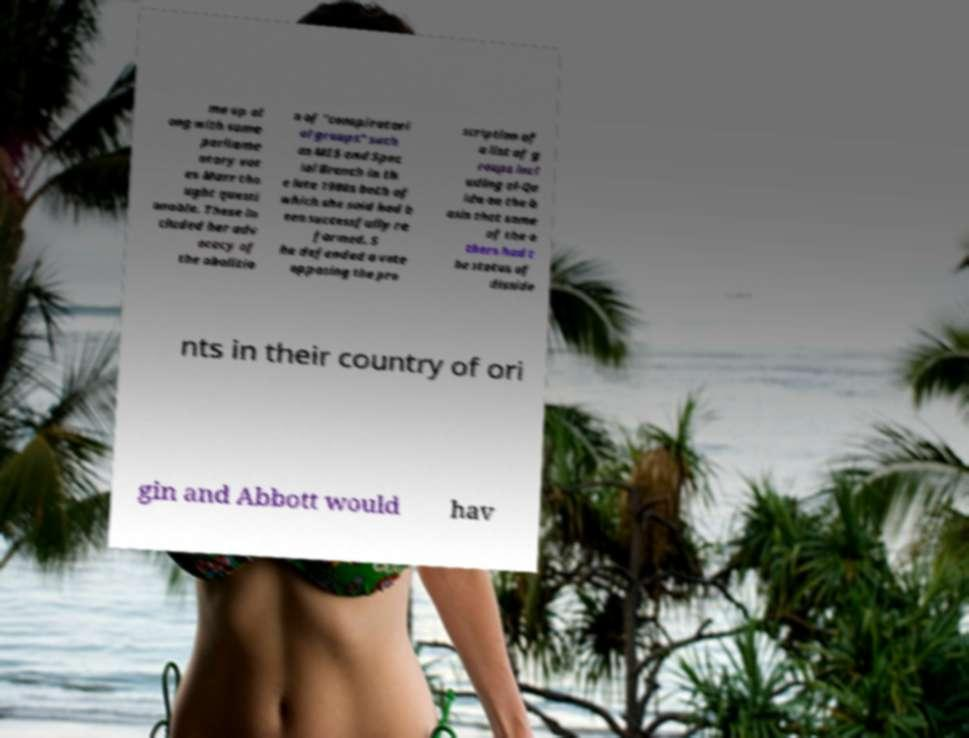Could you extract and type out the text from this image? me up al ong with some parliame ntary vot es Marr tho ught questi onable. These in cluded her adv ocacy of the abolitio n of "conspiratori al groups" such as MI5 and Spec ial Branch in th e late 1980s both of which she said had b een successfully re formed. S he defended a vote opposing the pro scription of a list of g roups incl uding al-Qa ida on the b asis that some of the o thers had t he status of disside nts in their country of ori gin and Abbott would hav 